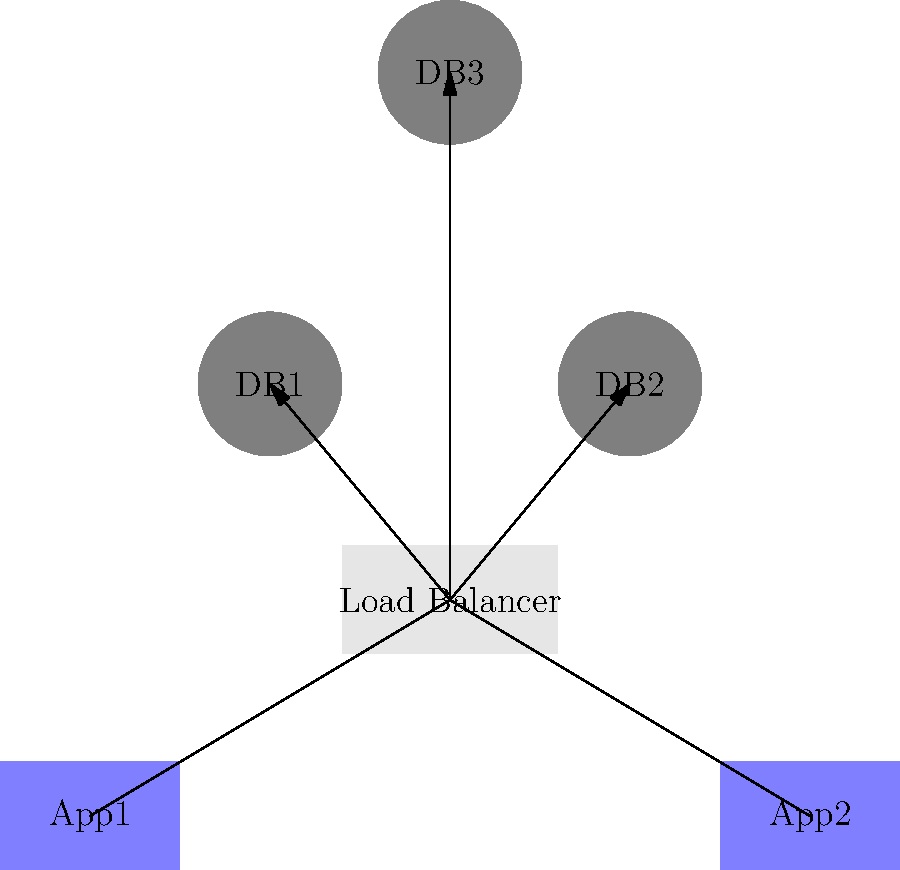In the distributed database system architecture shown above, what is the primary purpose of the Load Balancer component, and how does it contribute to the system's scalability and reliability? To understand the role of the Load Balancer in this distributed database system, let's break down the architecture and its components:

1. Clients (C1, C2, C3, C4): These represent end-users or applications that send requests to the system.

2. Application Servers (App1, App2): These servers handle client requests and interact with the database nodes.

3. Load Balancer: This component sits between the application servers and the database nodes.

4. Database Nodes (DB1, DB2, DB3): These represent the distributed database system, where data is stored and processed.

The Load Balancer serves several crucial purposes in this architecture:

1. Request Distribution: It evenly distributes incoming requests from the application servers across multiple database nodes. This prevents any single node from becoming a bottleneck.

2. Load Balancing: It ensures that the workload is balanced across all database nodes, optimizing resource utilization and improving overall system performance.

3. High Availability: If one database node fails or becomes unresponsive, the load balancer can redirect traffic to the remaining healthy nodes, ensuring continuous system operation.

4. Scalability: As the system grows, new database nodes can be added, and the load balancer can automatically include them in the request distribution, allowing the system to scale horizontally.

5. Fault Tolerance: By monitoring the health of database nodes, the load balancer can detect failures and stop sending requests to failed nodes, improving system reliability.

6. Performance Optimization: The load balancer can use various algorithms (e.g., round-robin, least connections) to optimize request distribution based on current system conditions.

By incorporating a load balancer, this distributed database system architecture achieves better scalability by allowing easy addition of new nodes, improved reliability through fault tolerance mechanisms, and enhanced performance through optimal request distribution.
Answer: Distribute requests, balance load, ensure high availability, enable scalability, and improve fault tolerance. 